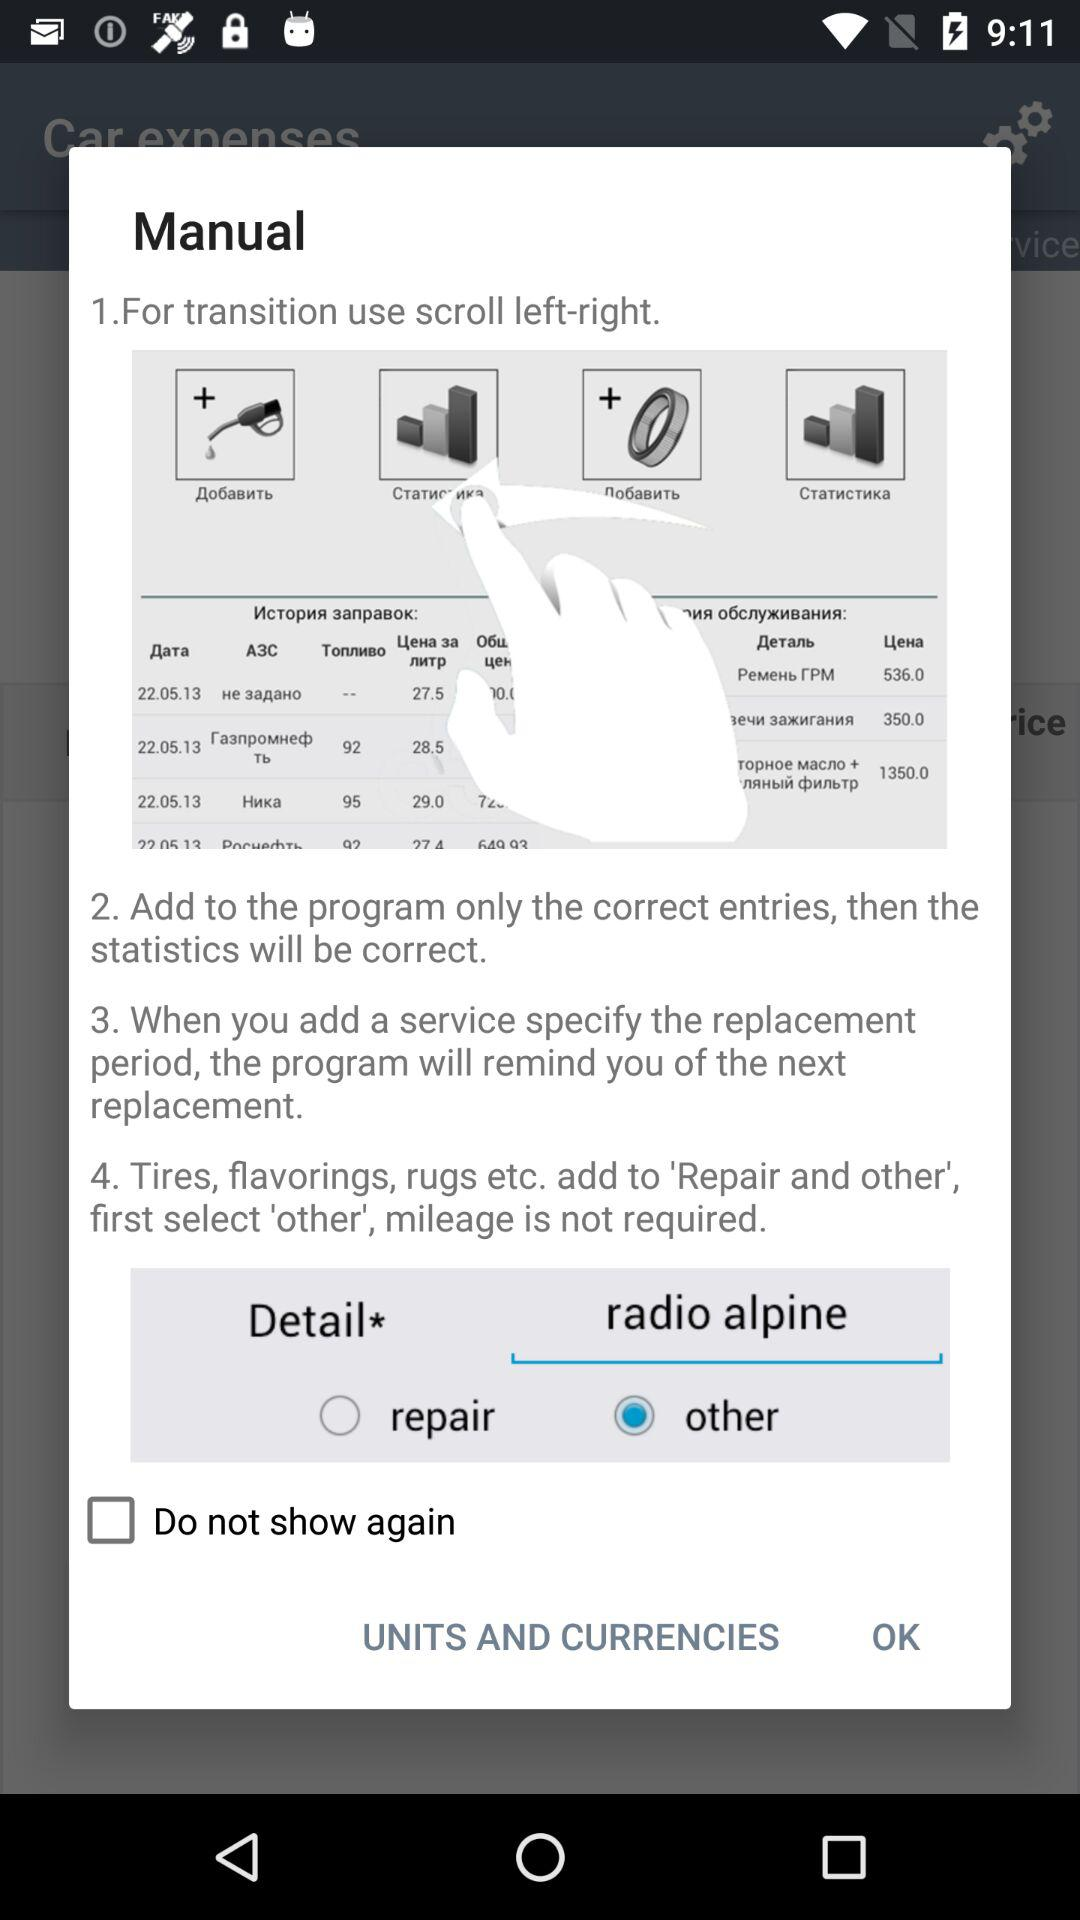How many steps are there in the maintenance process?
Answer the question using a single word or phrase. 4 